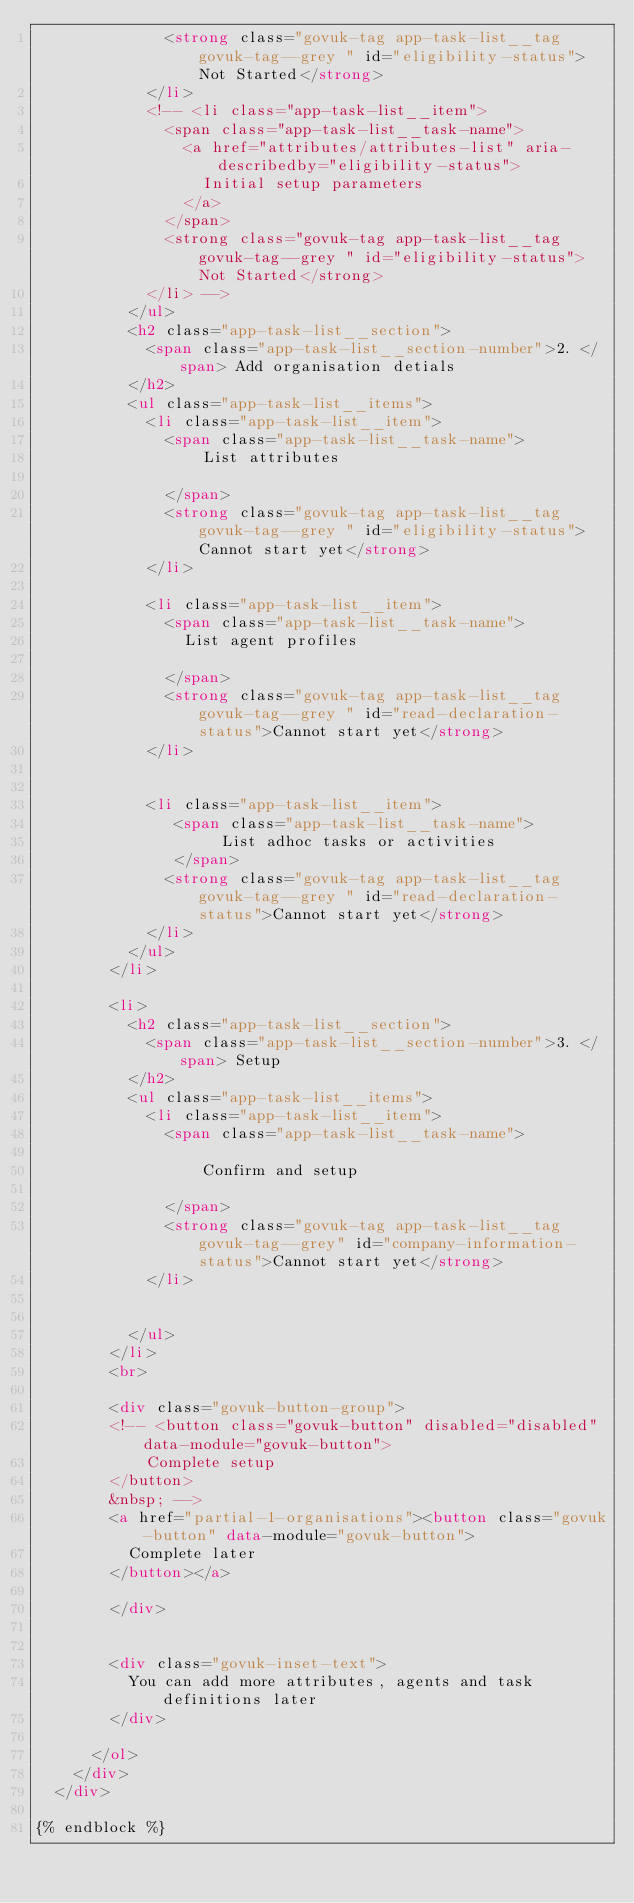Convert code to text. <code><loc_0><loc_0><loc_500><loc_500><_HTML_>              <strong class="govuk-tag app-task-list__tag govuk-tag--grey " id="eligibility-status">Not Started</strong>
            </li>
            <!-- <li class="app-task-list__item">
              <span class="app-task-list__task-name">
                <a href="attributes/attributes-list" aria-describedby="eligibility-status">
                  Initial setup parameters
                </a>
              </span>
              <strong class="govuk-tag app-task-list__tag govuk-tag--grey " id="eligibility-status">Not Started</strong>
            </li> -->
          </ul>
          <h2 class="app-task-list__section">
            <span class="app-task-list__section-number">2. </span> Add organisation detials
          </h2>
          <ul class="app-task-list__items">
            <li class="app-task-list__item">
              <span class="app-task-list__task-name">
                  List attributes

              </span>
              <strong class="govuk-tag app-task-list__tag govuk-tag--grey " id="eligibility-status">Cannot start yet</strong>
            </li>

            <li class="app-task-list__item">
              <span class="app-task-list__task-name">
                List agent profiles

              </span>
              <strong class="govuk-tag app-task-list__tag govuk-tag--grey " id="read-declaration-status">Cannot start yet</strong>
            </li>


            <li class="app-task-list__item">
               <span class="app-task-list__task-name">
                    List adhoc tasks or activities
               </span>
              <strong class="govuk-tag app-task-list__tag govuk-tag--grey " id="read-declaration-status">Cannot start yet</strong>
            </li>
          </ul>
        </li>

        <li>
          <h2 class="app-task-list__section">
            <span class="app-task-list__section-number">3. </span> Setup
          </h2>
          <ul class="app-task-list__items">
            <li class="app-task-list__item">
              <span class="app-task-list__task-name">

                  Confirm and setup

              </span>
              <strong class="govuk-tag app-task-list__tag govuk-tag--grey" id="company-information-status">Cannot start yet</strong>
            </li>


          </ul>
        </li>
        <br>

        <div class="govuk-button-group">
        <!-- <button class="govuk-button" disabled="disabled" data-module="govuk-button">
            Complete setup
        </button>
        &nbsp; -->
        <a href="partial-1-organisations"><button class="govuk-button" data-module="govuk-button">
          Complete later
        </button></a>

        </div>


        <div class="govuk-inset-text">
          You can add more attributes, agents and task definitions later
        </div>

      </ol>
    </div>
  </div>

{% endblock %}
</code> 